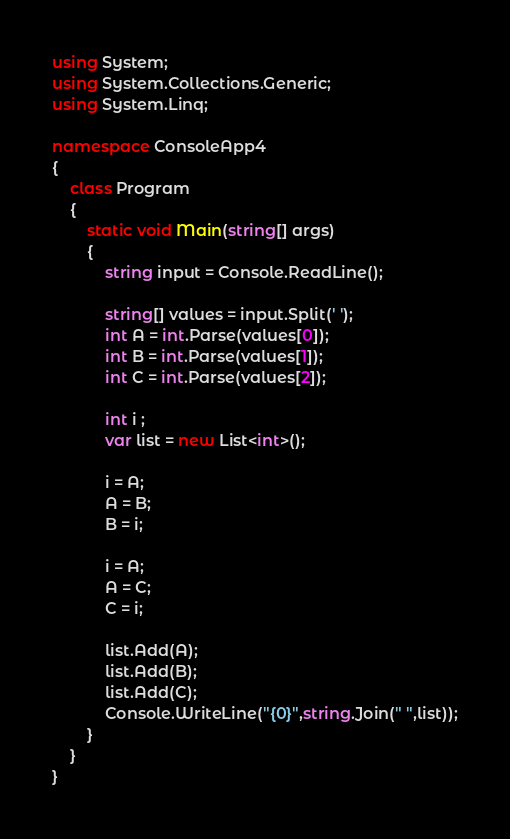<code> <loc_0><loc_0><loc_500><loc_500><_C#_>using System;
using System.Collections.Generic;
using System.Linq;

namespace ConsoleApp4
{
    class Program
    {
        static void Main(string[] args)
        {
            string input = Console.ReadLine();

            string[] values = input.Split(' ');
            int A = int.Parse(values[0]);
            int B = int.Parse(values[1]);
            int C = int.Parse(values[2]);

            int i ;
            var list = new List<int>();

            i = A;
            A = B;
            B = i;

            i = A;
            A = C;
            C = i;

            list.Add(A);
            list.Add(B);
            list.Add(C);
            Console.WriteLine("{0}",string.Join(" ",list));
        }
    }
}</code> 